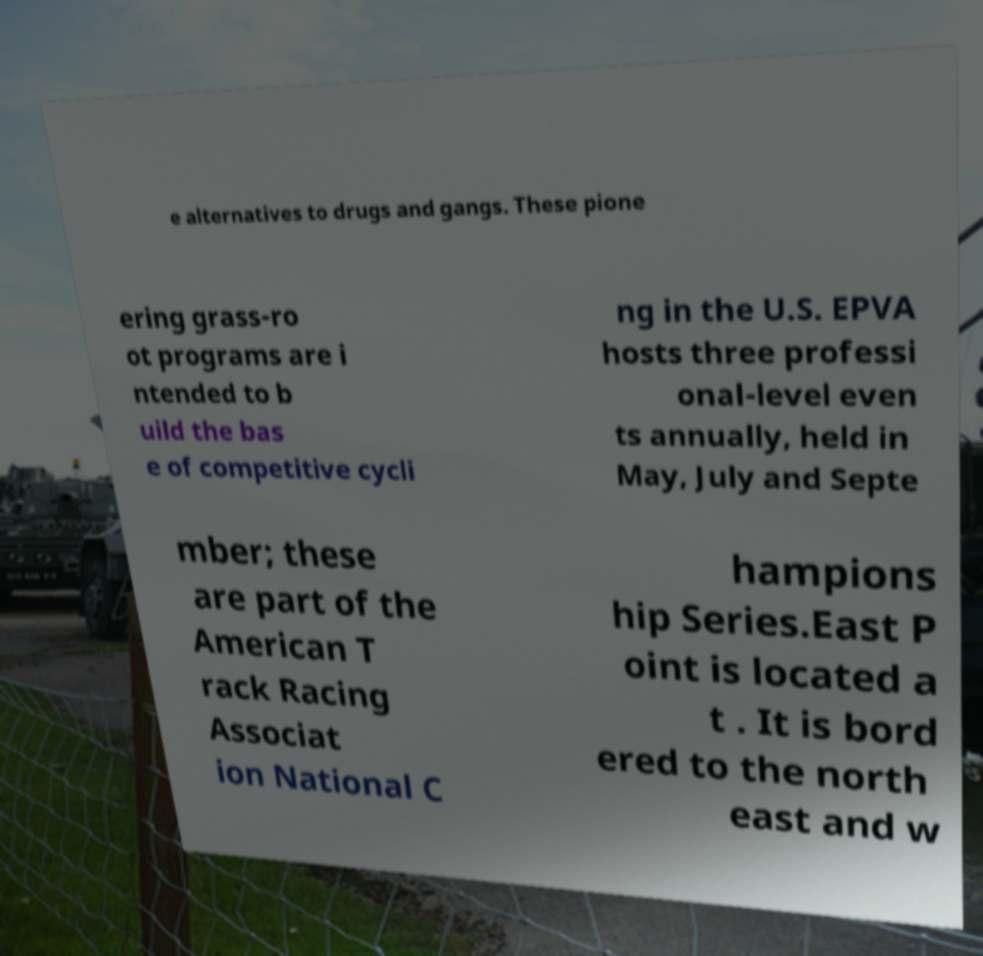Please read and relay the text visible in this image. What does it say? e alternatives to drugs and gangs. These pione ering grass-ro ot programs are i ntended to b uild the bas e of competitive cycli ng in the U.S. EPVA hosts three professi onal-level even ts annually, held in May, July and Septe mber; these are part of the American T rack Racing Associat ion National C hampions hip Series.East P oint is located a t . It is bord ered to the north east and w 